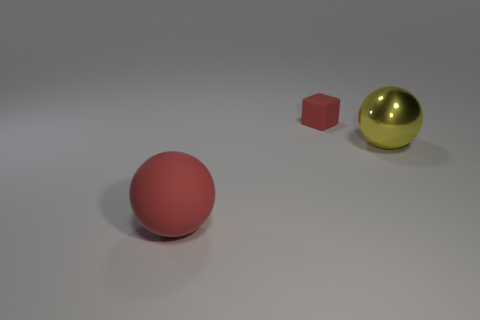Are there any other things that have the same material as the big yellow sphere?
Ensure brevity in your answer.  No. Is the number of yellow spheres less than the number of small blue metallic balls?
Give a very brief answer. No. There is a large metal thing; is its shape the same as the red rubber thing behind the yellow metallic ball?
Provide a short and direct response. No. Does the object right of the red rubber block have the same size as the big red rubber object?
Your response must be concise. Yes. The red thing that is the same size as the yellow metallic sphere is what shape?
Your response must be concise. Sphere. Is the shape of the big yellow metallic thing the same as the tiny matte object?
Keep it short and to the point. No. What number of large red matte objects are the same shape as the big yellow metallic object?
Offer a very short reply. 1. How many rubber spheres are in front of the tiny matte thing?
Give a very brief answer. 1. There is a rubber thing behind the big red rubber sphere; is its color the same as the large rubber sphere?
Provide a succinct answer. Yes. How many other rubber balls have the same size as the yellow sphere?
Ensure brevity in your answer.  1. 